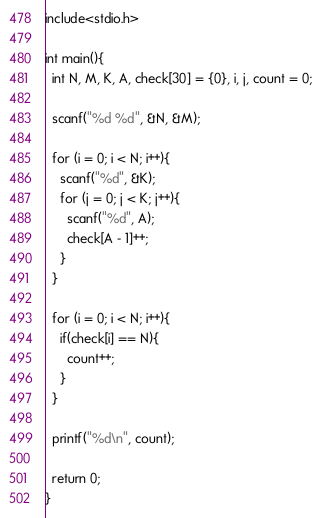Convert code to text. <code><loc_0><loc_0><loc_500><loc_500><_C_>include<stdio.h>
  
int main(){
  int N, M, K, A, check[30] = {0}, i, j, count = 0;
  
  scanf("%d %d", &N, &M);
  
  for (i = 0; i < N; i++){
    scanf("%d", &K);
    for (j = 0; j < K; j++){
      scanf("%d", A);
      check[A - 1]++;
    }
  }
  
  for (i = 0; i < N; i++){
    if(check[i] == N){
      count++;
    }
  }
  
  printf("%d\n", count);
  
  return 0;
}</code> 